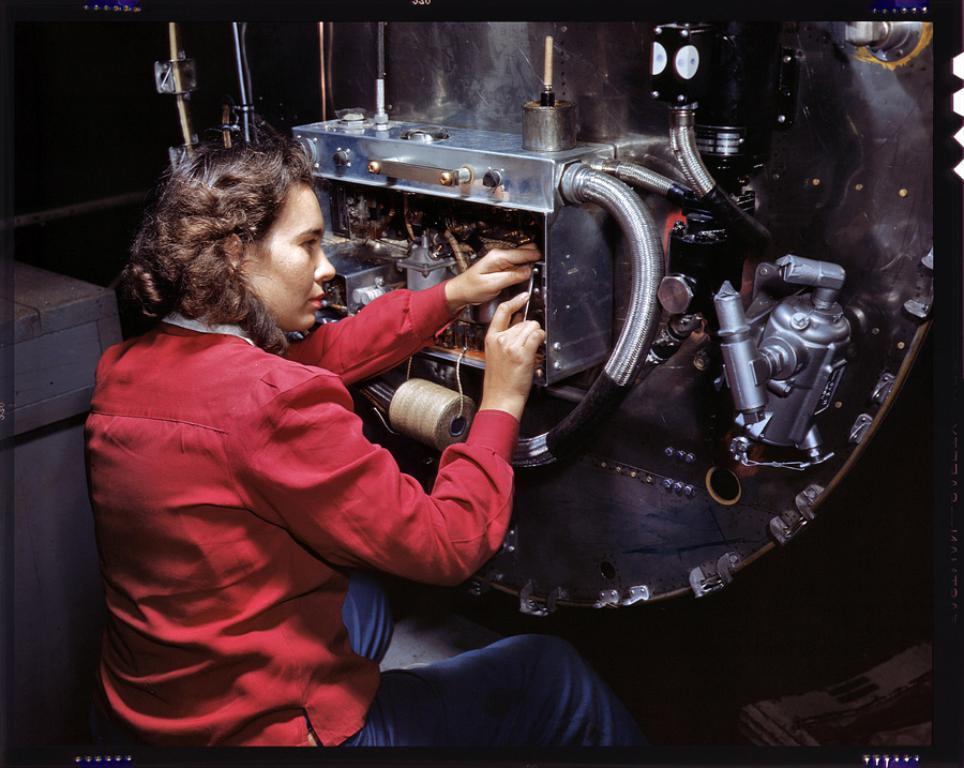In one or two sentences, can you explain what this image depicts? This image is taken indoors. On the left side of the image there is a table and a woman is sitting on the stool and she is repairing a machine. In the middle of the image there is a machine with a motor, wires and a few things. 